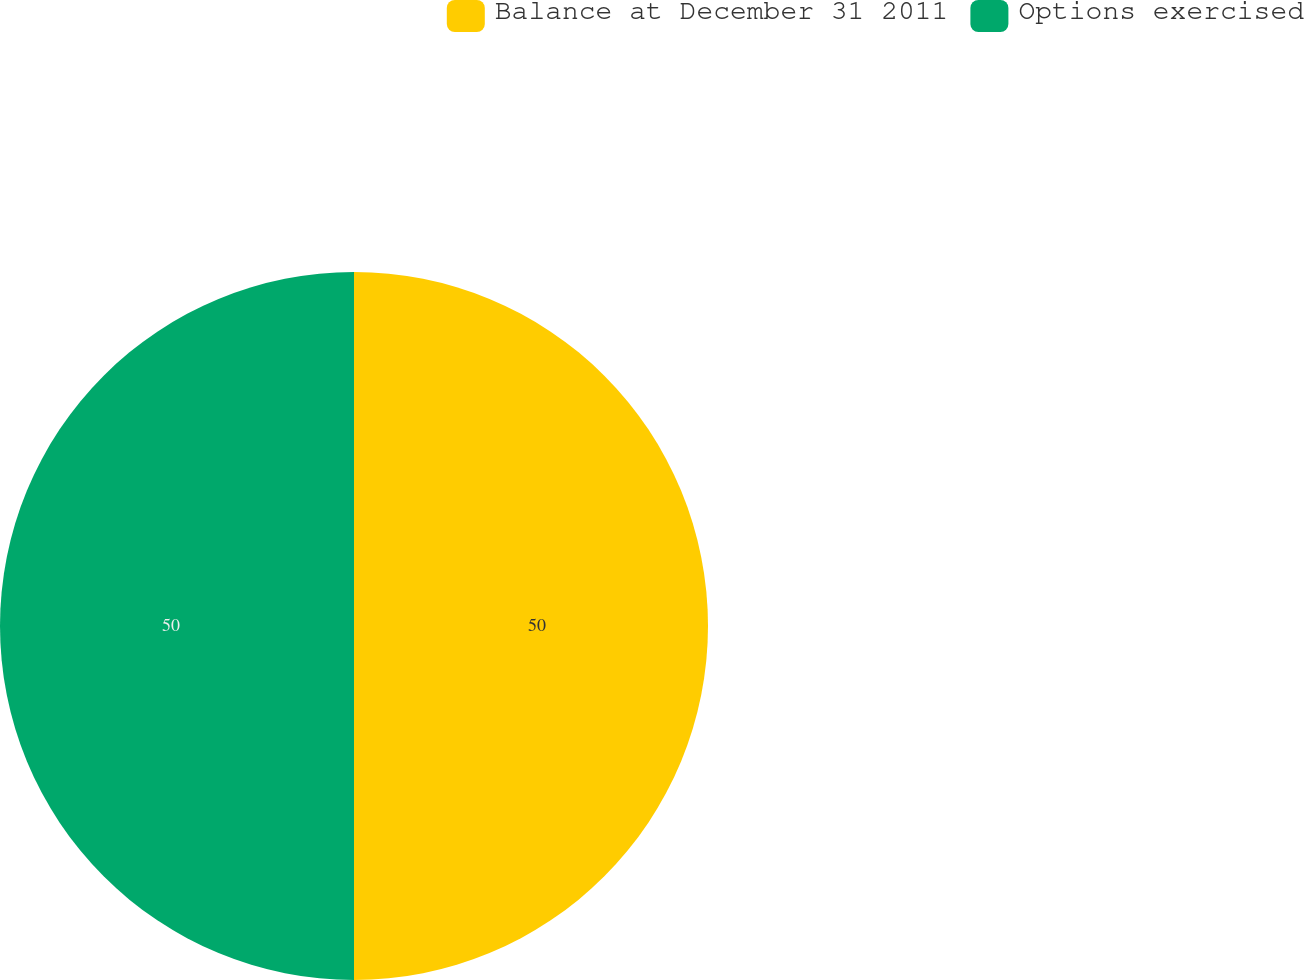<chart> <loc_0><loc_0><loc_500><loc_500><pie_chart><fcel>Balance at December 31 2011<fcel>Options exercised<nl><fcel>50.0%<fcel>50.0%<nl></chart> 